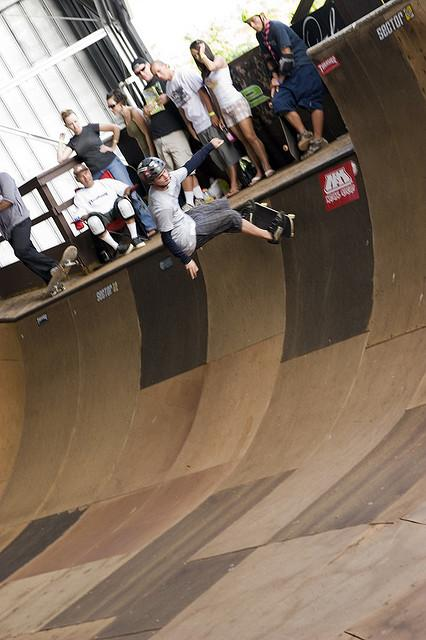What is the man skateboarding on?

Choices:
A) half pipe
B) training ramp
C) full pipe
D) tech deck half pipe 